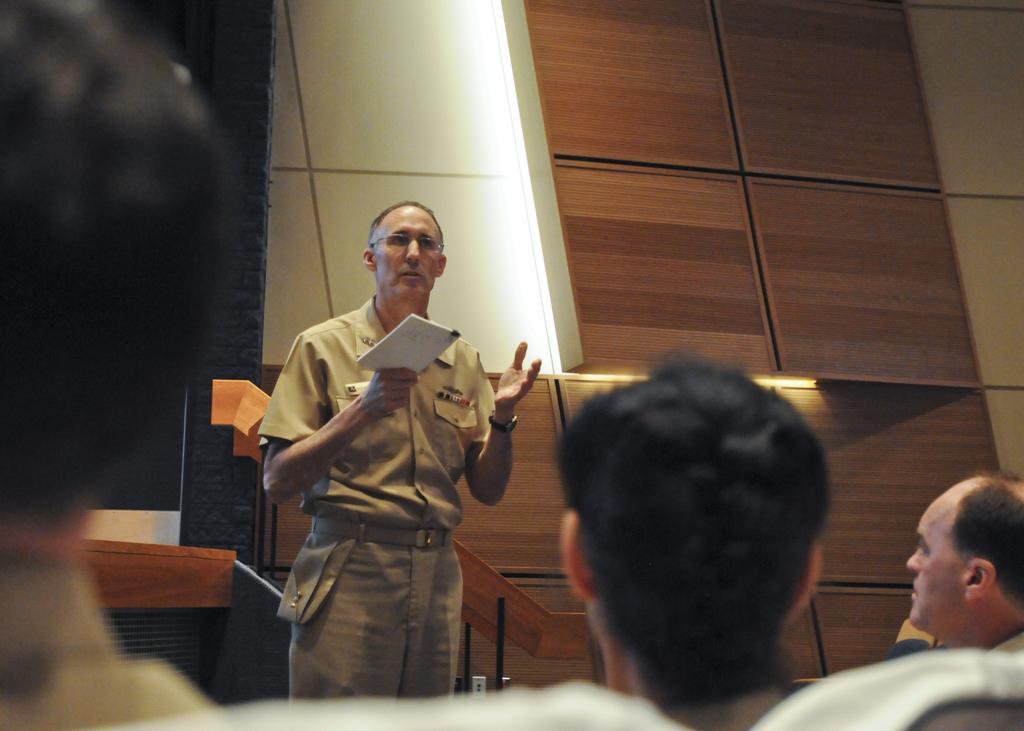Describe this image in one or two sentences. This image consists of four persons. In the front, we can see a man holding a book and standing. In the background, it looks like a wall. And we can see the wooden planks. 